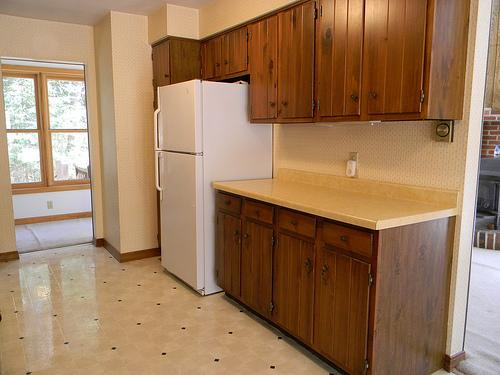Describe the floor's pattern and material in the image. The kitchen floor has black diamond-shaped patterns over linoleum material. Specify the distinct parts visible within the kitchen cabinets. The wooden cabinets have metal handles, a countertop, and wooden baseboard trimmings. Describe any distinctive marks visible on the floor in the image. Several black marks are spotted on the floor at different locations. Give a brief description of the view outside the window in the image. Outside the window, there are trees and a brick wall in the background. Summarize the overall theme of the image in a short sentence. A cozy, well-furnished kitchen with various wooden elements and a window with a view. Mention the color and positioning of the refrigerator in the image. The refrigerator is white and is located in the foreground of the image. Describe the general setting of the image. An indoor kitchen scene with various wooden cabinets, a white refrigerator, a large window showing the outside, and checkered linoleum flooring. Describe the power outlets seen in the image. There is a wall power outlet and another outlet with an air freshener plugged in. Mention some prominent characteristics of the kitchen cabinets. The kitchen cabinets are wooden with metal handles and contribute to a cozy atmosphere. What type of frame is surrounding the window in the image? A white frame is surrounding the window in the image. 